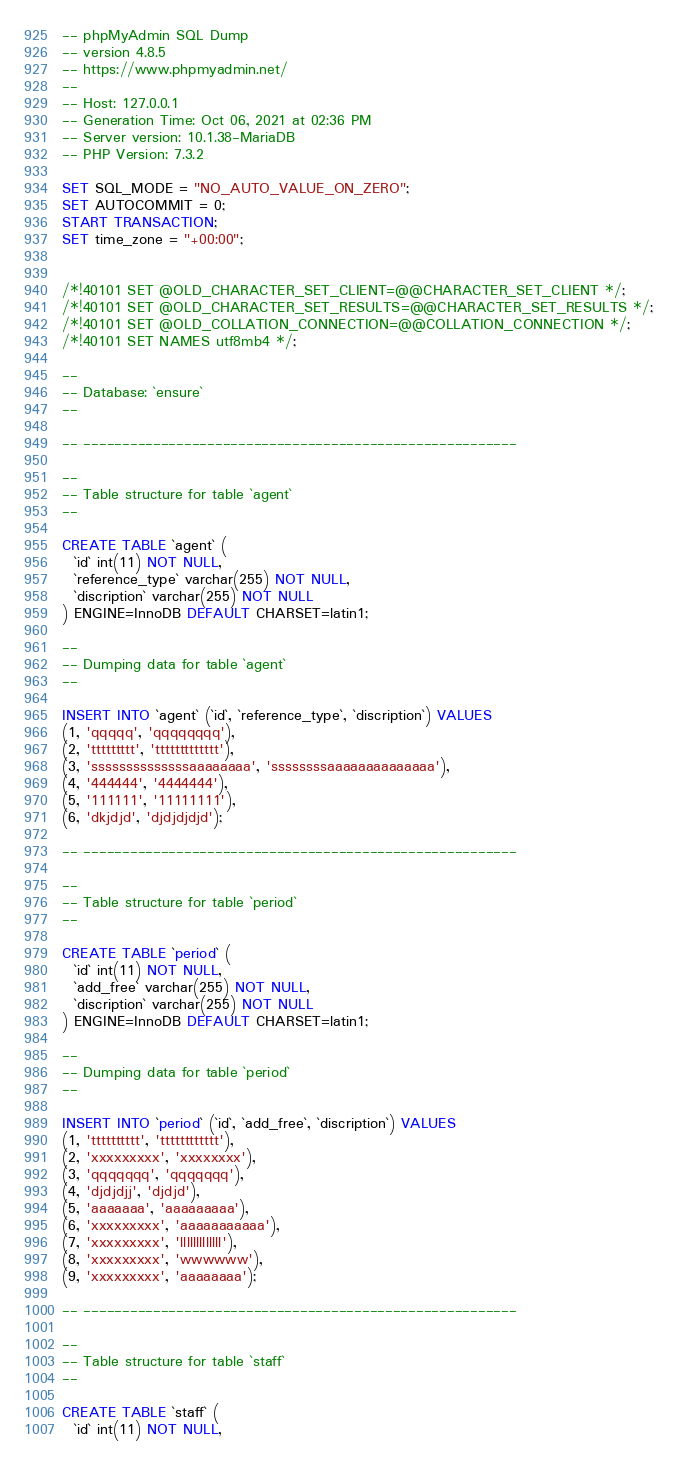<code> <loc_0><loc_0><loc_500><loc_500><_SQL_>-- phpMyAdmin SQL Dump
-- version 4.8.5
-- https://www.phpmyadmin.net/
--
-- Host: 127.0.0.1
-- Generation Time: Oct 06, 2021 at 02:36 PM
-- Server version: 10.1.38-MariaDB
-- PHP Version: 7.3.2

SET SQL_MODE = "NO_AUTO_VALUE_ON_ZERO";
SET AUTOCOMMIT = 0;
START TRANSACTION;
SET time_zone = "+00:00";


/*!40101 SET @OLD_CHARACTER_SET_CLIENT=@@CHARACTER_SET_CLIENT */;
/*!40101 SET @OLD_CHARACTER_SET_RESULTS=@@CHARACTER_SET_RESULTS */;
/*!40101 SET @OLD_COLLATION_CONNECTION=@@COLLATION_CONNECTION */;
/*!40101 SET NAMES utf8mb4 */;

--
-- Database: `ensure`
--

-- --------------------------------------------------------

--
-- Table structure for table `agent`
--

CREATE TABLE `agent` (
  `id` int(11) NOT NULL,
  `reference_type` varchar(255) NOT NULL,
  `discription` varchar(255) NOT NULL
) ENGINE=InnoDB DEFAULT CHARSET=latin1;

--
-- Dumping data for table `agent`
--

INSERT INTO `agent` (`id`, `reference_type`, `discription`) VALUES
(1, 'qqqqq', 'qqqqqqqq'),
(2, 'ttttttttt', 'ttttttttttttt'),
(3, 'ssssssssssssssaaaaaaaa', 'ssssssssaaaaaaaaaaaaaa'),
(4, '444444', '4444444'),
(5, '111111', '11111111'),
(6, 'dkjdjd', 'djdjdjdjd');

-- --------------------------------------------------------

--
-- Table structure for table `period`
--

CREATE TABLE `period` (
  `id` int(11) NOT NULL,
  `add_free` varchar(255) NOT NULL,
  `discription` varchar(255) NOT NULL
) ENGINE=InnoDB DEFAULT CHARSET=latin1;

--
-- Dumping data for table `period`
--

INSERT INTO `period` (`id`, `add_free`, `discription`) VALUES
(1, 'tttttttttt', 'tttttttttttt'),
(2, 'xxxxxxxxx', 'xxxxxxxx'),
(3, 'qqqqqqq', 'qqqqqqq'),
(4, 'djdjdjj', 'djdjd'),
(5, 'aaaaaaa', 'aaaaaaaaa'),
(6, 'xxxxxxxxx', 'aaaaaaaaaaa'),
(7, 'xxxxxxxxx', 'lllllllllllll'),
(8, 'xxxxxxxxx', 'wwwwww'),
(9, 'xxxxxxxxx', 'aaaaaaaa');

-- --------------------------------------------------------

--
-- Table structure for table `staff`
--

CREATE TABLE `staff` (
  `id` int(11) NOT NULL,</code> 